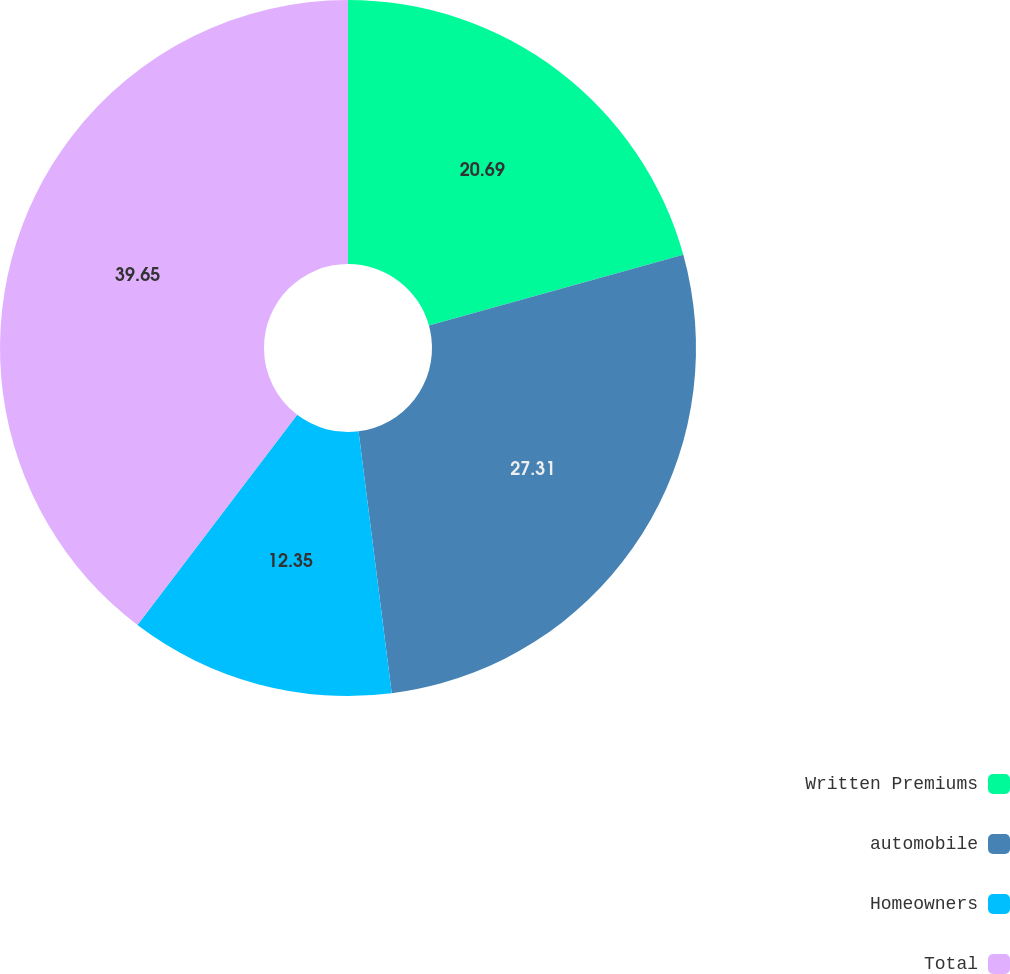<chart> <loc_0><loc_0><loc_500><loc_500><pie_chart><fcel>Written Premiums<fcel>automobile<fcel>Homeowners<fcel>Total<nl><fcel>20.69%<fcel>27.31%<fcel>12.35%<fcel>39.66%<nl></chart> 